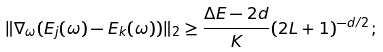Convert formula to latex. <formula><loc_0><loc_0><loc_500><loc_500>\| \nabla _ { \omega } ( E _ { j } ( \omega ) - E _ { k } ( \omega ) ) \| _ { 2 } \geq \frac { \Delta E - 2 d } { K } ( 2 L + 1 ) ^ { - d / 2 } ;</formula> 